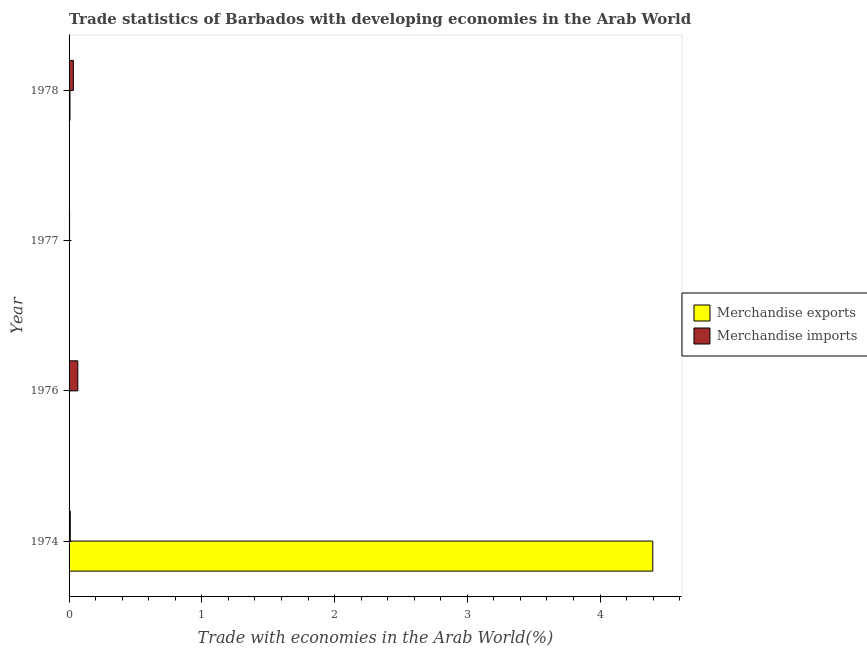How many different coloured bars are there?
Provide a succinct answer. 2. Are the number of bars per tick equal to the number of legend labels?
Give a very brief answer. Yes. Are the number of bars on each tick of the Y-axis equal?
Ensure brevity in your answer.  Yes. How many bars are there on the 3rd tick from the top?
Your answer should be very brief. 2. How many bars are there on the 2nd tick from the bottom?
Provide a succinct answer. 2. What is the label of the 3rd group of bars from the top?
Ensure brevity in your answer.  1976. What is the merchandise exports in 1978?
Give a very brief answer. 0.01. Across all years, what is the maximum merchandise exports?
Offer a very short reply. 4.4. Across all years, what is the minimum merchandise exports?
Provide a short and direct response. 0. In which year was the merchandise exports maximum?
Make the answer very short. 1974. What is the total merchandise exports in the graph?
Your answer should be compact. 4.41. What is the difference between the merchandise exports in 1976 and that in 1978?
Your response must be concise. -0.01. What is the difference between the merchandise imports in 1977 and the merchandise exports in 1978?
Your answer should be compact. -0. What is the average merchandise exports per year?
Provide a short and direct response. 1.1. In the year 1974, what is the difference between the merchandise imports and merchandise exports?
Offer a terse response. -4.39. In how many years, is the merchandise exports greater than 2.2 %?
Offer a terse response. 1. What is the ratio of the merchandise exports in 1976 to that in 1977?
Offer a terse response. 0.74. Is the merchandise imports in 1977 less than that in 1978?
Keep it short and to the point. Yes. Is the difference between the merchandise imports in 1976 and 1978 greater than the difference between the merchandise exports in 1976 and 1978?
Provide a succinct answer. Yes. What is the difference between the highest and the second highest merchandise imports?
Your answer should be very brief. 0.03. What is the difference between the highest and the lowest merchandise imports?
Offer a very short reply. 0.06. In how many years, is the merchandise imports greater than the average merchandise imports taken over all years?
Ensure brevity in your answer.  2. What does the 1st bar from the top in 1976 represents?
Make the answer very short. Merchandise imports. How many bars are there?
Your response must be concise. 8. What is the difference between two consecutive major ticks on the X-axis?
Make the answer very short. 1. Are the values on the major ticks of X-axis written in scientific E-notation?
Keep it short and to the point. No. How are the legend labels stacked?
Provide a succinct answer. Vertical. What is the title of the graph?
Keep it short and to the point. Trade statistics of Barbados with developing economies in the Arab World. Does "Mineral" appear as one of the legend labels in the graph?
Offer a very short reply. No. What is the label or title of the X-axis?
Keep it short and to the point. Trade with economies in the Arab World(%). What is the label or title of the Y-axis?
Give a very brief answer. Year. What is the Trade with economies in the Arab World(%) of Merchandise exports in 1974?
Your answer should be compact. 4.4. What is the Trade with economies in the Arab World(%) of Merchandise imports in 1974?
Your response must be concise. 0.01. What is the Trade with economies in the Arab World(%) in Merchandise exports in 1976?
Your answer should be compact. 0. What is the Trade with economies in the Arab World(%) in Merchandise imports in 1976?
Provide a short and direct response. 0.07. What is the Trade with economies in the Arab World(%) of Merchandise exports in 1977?
Give a very brief answer. 0. What is the Trade with economies in the Arab World(%) in Merchandise imports in 1977?
Ensure brevity in your answer.  0. What is the Trade with economies in the Arab World(%) of Merchandise exports in 1978?
Your answer should be very brief. 0.01. What is the Trade with economies in the Arab World(%) of Merchandise imports in 1978?
Give a very brief answer. 0.03. Across all years, what is the maximum Trade with economies in the Arab World(%) in Merchandise exports?
Your response must be concise. 4.4. Across all years, what is the maximum Trade with economies in the Arab World(%) in Merchandise imports?
Keep it short and to the point. 0.07. Across all years, what is the minimum Trade with economies in the Arab World(%) in Merchandise exports?
Make the answer very short. 0. Across all years, what is the minimum Trade with economies in the Arab World(%) of Merchandise imports?
Provide a succinct answer. 0. What is the total Trade with economies in the Arab World(%) of Merchandise exports in the graph?
Keep it short and to the point. 4.41. What is the total Trade with economies in the Arab World(%) of Merchandise imports in the graph?
Provide a succinct answer. 0.11. What is the difference between the Trade with economies in the Arab World(%) in Merchandise exports in 1974 and that in 1976?
Your response must be concise. 4.39. What is the difference between the Trade with economies in the Arab World(%) of Merchandise imports in 1974 and that in 1976?
Keep it short and to the point. -0.06. What is the difference between the Trade with economies in the Arab World(%) in Merchandise exports in 1974 and that in 1977?
Offer a very short reply. 4.39. What is the difference between the Trade with economies in the Arab World(%) in Merchandise imports in 1974 and that in 1977?
Your answer should be very brief. 0.01. What is the difference between the Trade with economies in the Arab World(%) in Merchandise exports in 1974 and that in 1978?
Your answer should be compact. 4.39. What is the difference between the Trade with economies in the Arab World(%) in Merchandise imports in 1974 and that in 1978?
Make the answer very short. -0.02. What is the difference between the Trade with economies in the Arab World(%) in Merchandise exports in 1976 and that in 1977?
Your answer should be very brief. -0. What is the difference between the Trade with economies in the Arab World(%) in Merchandise imports in 1976 and that in 1977?
Offer a terse response. 0.06. What is the difference between the Trade with economies in the Arab World(%) in Merchandise exports in 1976 and that in 1978?
Your answer should be compact. -0. What is the difference between the Trade with economies in the Arab World(%) in Merchandise imports in 1976 and that in 1978?
Provide a short and direct response. 0.03. What is the difference between the Trade with economies in the Arab World(%) in Merchandise exports in 1977 and that in 1978?
Your response must be concise. -0. What is the difference between the Trade with economies in the Arab World(%) of Merchandise imports in 1977 and that in 1978?
Offer a terse response. -0.03. What is the difference between the Trade with economies in the Arab World(%) of Merchandise exports in 1974 and the Trade with economies in the Arab World(%) of Merchandise imports in 1976?
Provide a succinct answer. 4.33. What is the difference between the Trade with economies in the Arab World(%) in Merchandise exports in 1974 and the Trade with economies in the Arab World(%) in Merchandise imports in 1977?
Your answer should be very brief. 4.39. What is the difference between the Trade with economies in the Arab World(%) of Merchandise exports in 1974 and the Trade with economies in the Arab World(%) of Merchandise imports in 1978?
Offer a terse response. 4.36. What is the difference between the Trade with economies in the Arab World(%) of Merchandise exports in 1976 and the Trade with economies in the Arab World(%) of Merchandise imports in 1977?
Your answer should be compact. -0. What is the difference between the Trade with economies in the Arab World(%) in Merchandise exports in 1976 and the Trade with economies in the Arab World(%) in Merchandise imports in 1978?
Ensure brevity in your answer.  -0.03. What is the difference between the Trade with economies in the Arab World(%) of Merchandise exports in 1977 and the Trade with economies in the Arab World(%) of Merchandise imports in 1978?
Offer a very short reply. -0.03. What is the average Trade with economies in the Arab World(%) in Merchandise exports per year?
Provide a succinct answer. 1.1. What is the average Trade with economies in the Arab World(%) of Merchandise imports per year?
Make the answer very short. 0.03. In the year 1974, what is the difference between the Trade with economies in the Arab World(%) of Merchandise exports and Trade with economies in the Arab World(%) of Merchandise imports?
Your answer should be compact. 4.39. In the year 1976, what is the difference between the Trade with economies in the Arab World(%) in Merchandise exports and Trade with economies in the Arab World(%) in Merchandise imports?
Offer a very short reply. -0.06. In the year 1977, what is the difference between the Trade with economies in the Arab World(%) in Merchandise exports and Trade with economies in the Arab World(%) in Merchandise imports?
Make the answer very short. -0. In the year 1978, what is the difference between the Trade with economies in the Arab World(%) in Merchandise exports and Trade with economies in the Arab World(%) in Merchandise imports?
Your answer should be very brief. -0.03. What is the ratio of the Trade with economies in the Arab World(%) of Merchandise exports in 1974 to that in 1976?
Your answer should be compact. 1898.92. What is the ratio of the Trade with economies in the Arab World(%) of Merchandise imports in 1974 to that in 1976?
Provide a short and direct response. 0.13. What is the ratio of the Trade with economies in the Arab World(%) of Merchandise exports in 1974 to that in 1977?
Provide a succinct answer. 1398.03. What is the ratio of the Trade with economies in the Arab World(%) of Merchandise imports in 1974 to that in 1977?
Ensure brevity in your answer.  2.41. What is the ratio of the Trade with economies in the Arab World(%) in Merchandise exports in 1974 to that in 1978?
Give a very brief answer. 634.29. What is the ratio of the Trade with economies in the Arab World(%) of Merchandise imports in 1974 to that in 1978?
Keep it short and to the point. 0.27. What is the ratio of the Trade with economies in the Arab World(%) of Merchandise exports in 1976 to that in 1977?
Provide a short and direct response. 0.74. What is the ratio of the Trade with economies in the Arab World(%) in Merchandise imports in 1976 to that in 1977?
Offer a very short reply. 18.01. What is the ratio of the Trade with economies in the Arab World(%) of Merchandise exports in 1976 to that in 1978?
Your answer should be very brief. 0.33. What is the ratio of the Trade with economies in the Arab World(%) of Merchandise imports in 1976 to that in 1978?
Keep it short and to the point. 2.04. What is the ratio of the Trade with economies in the Arab World(%) of Merchandise exports in 1977 to that in 1978?
Ensure brevity in your answer.  0.45. What is the ratio of the Trade with economies in the Arab World(%) of Merchandise imports in 1977 to that in 1978?
Your response must be concise. 0.11. What is the difference between the highest and the second highest Trade with economies in the Arab World(%) of Merchandise exports?
Offer a very short reply. 4.39. What is the difference between the highest and the second highest Trade with economies in the Arab World(%) of Merchandise imports?
Provide a short and direct response. 0.03. What is the difference between the highest and the lowest Trade with economies in the Arab World(%) in Merchandise exports?
Offer a very short reply. 4.39. What is the difference between the highest and the lowest Trade with economies in the Arab World(%) in Merchandise imports?
Make the answer very short. 0.06. 